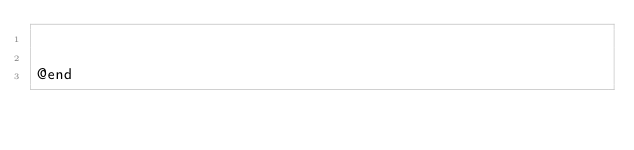Convert code to text. <code><loc_0><loc_0><loc_500><loc_500><_C_>

@end
</code> 